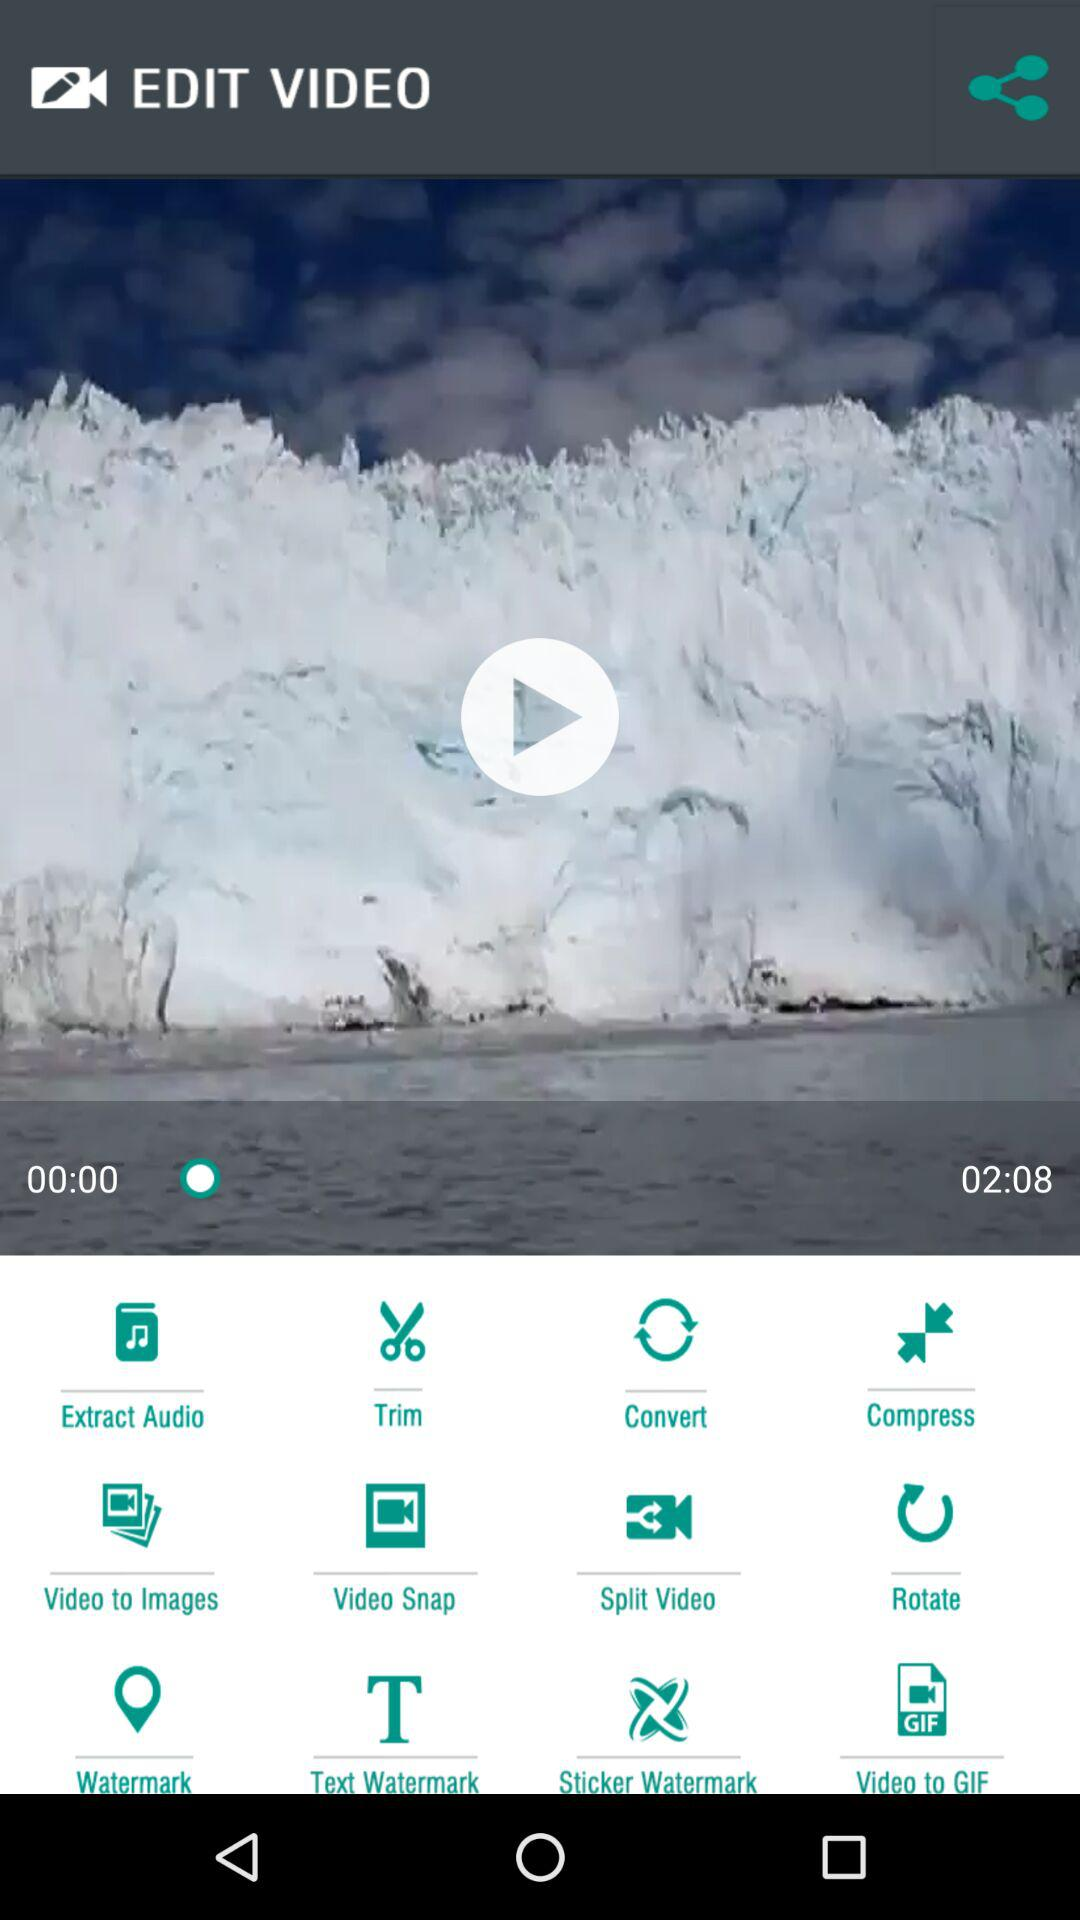When was the video posted?
When the provided information is insufficient, respond with <no answer>. <no answer> 